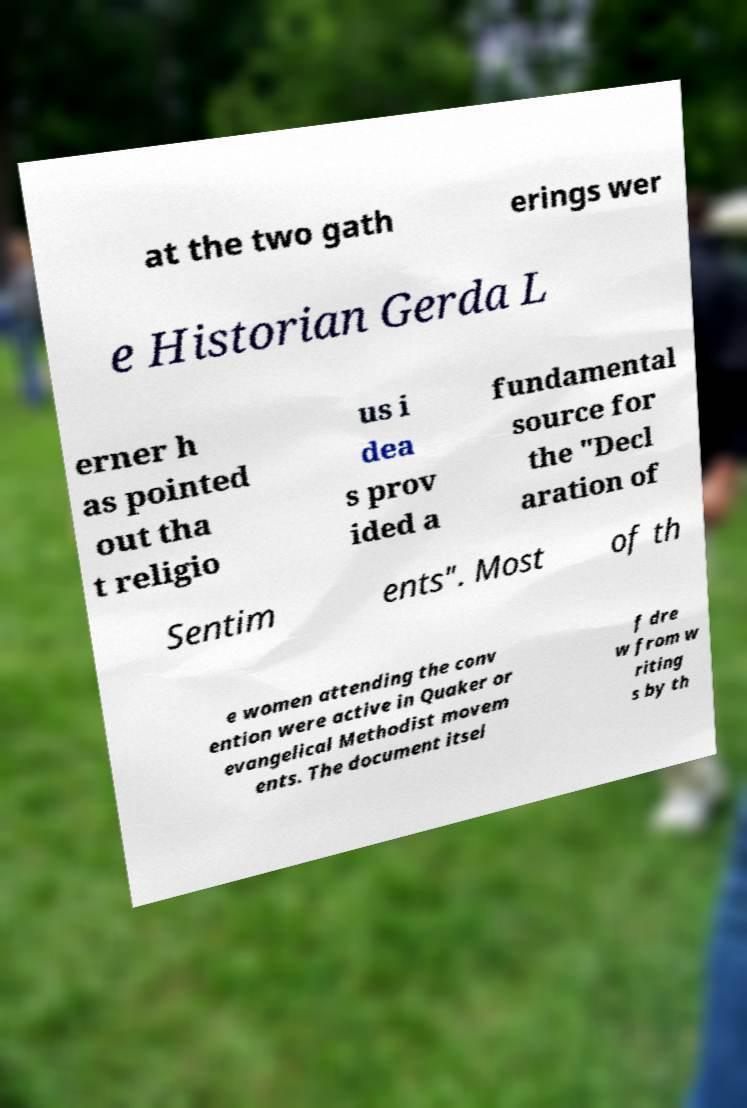Please read and relay the text visible in this image. What does it say? at the two gath erings wer e Historian Gerda L erner h as pointed out tha t religio us i dea s prov ided a fundamental source for the "Decl aration of Sentim ents". Most of th e women attending the conv ention were active in Quaker or evangelical Methodist movem ents. The document itsel f dre w from w riting s by th 